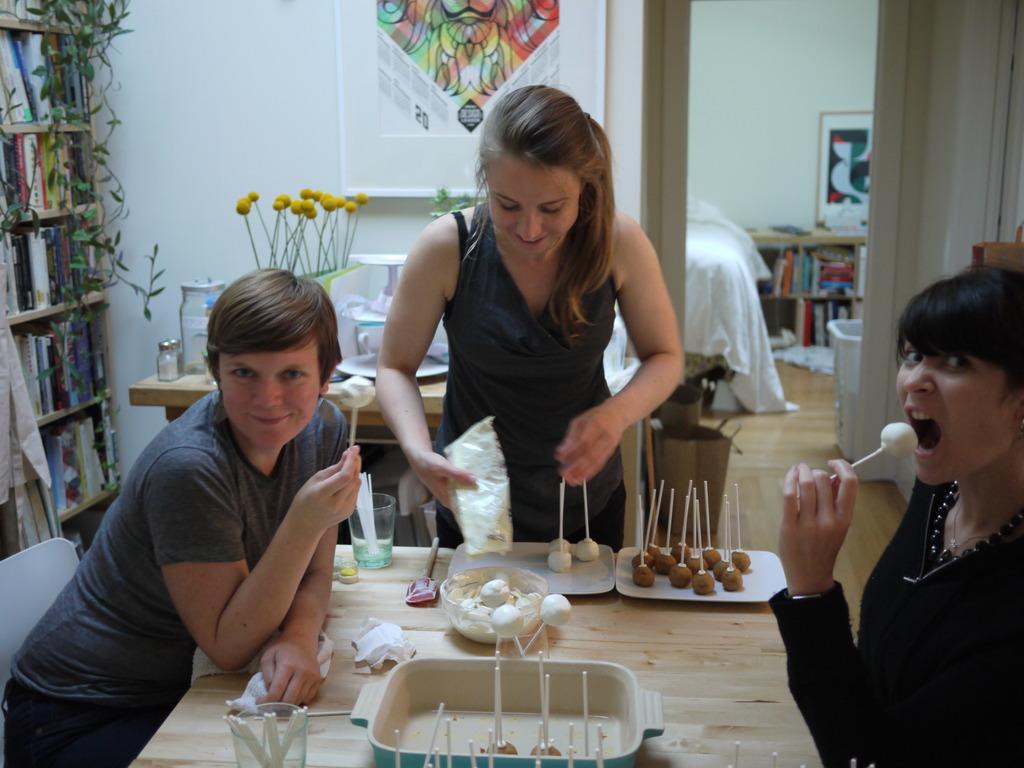How would you summarize this image in a sentence or two? This is a table with a bowl,plates,glass and some other objects on it. There are two persons sitting on the chairs and one women is standing. This looks like another room with a bed. Here is another table with some glass jars and other things. This is a poster attached to the wall. Here this looks like a bookshelf were some books are placed in it. 